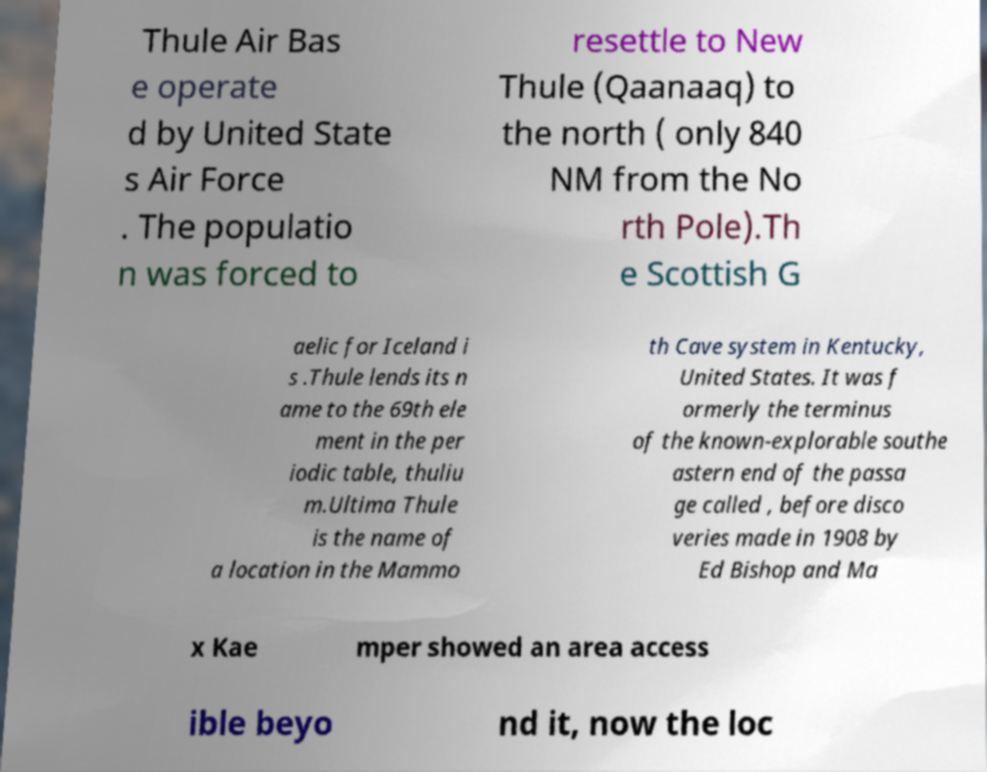Can you read and provide the text displayed in the image?This photo seems to have some interesting text. Can you extract and type it out for me? Thule Air Bas e operate d by United State s Air Force . The populatio n was forced to resettle to New Thule (Qaanaaq) to the north ( only 840 NM from the No rth Pole).Th e Scottish G aelic for Iceland i s .Thule lends its n ame to the 69th ele ment in the per iodic table, thuliu m.Ultima Thule is the name of a location in the Mammo th Cave system in Kentucky, United States. It was f ormerly the terminus of the known-explorable southe astern end of the passa ge called , before disco veries made in 1908 by Ed Bishop and Ma x Kae mper showed an area access ible beyo nd it, now the loc 